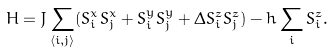<formula> <loc_0><loc_0><loc_500><loc_500>H = J \sum _ { \langle i , j \rangle } ( S ^ { x } _ { i } S ^ { x } _ { j } + S ^ { y } _ { i } S ^ { y } _ { j } + \Delta S ^ { z } _ { i } S ^ { z } _ { j } ) - h \sum _ { i } S ^ { z } _ { i } .</formula> 